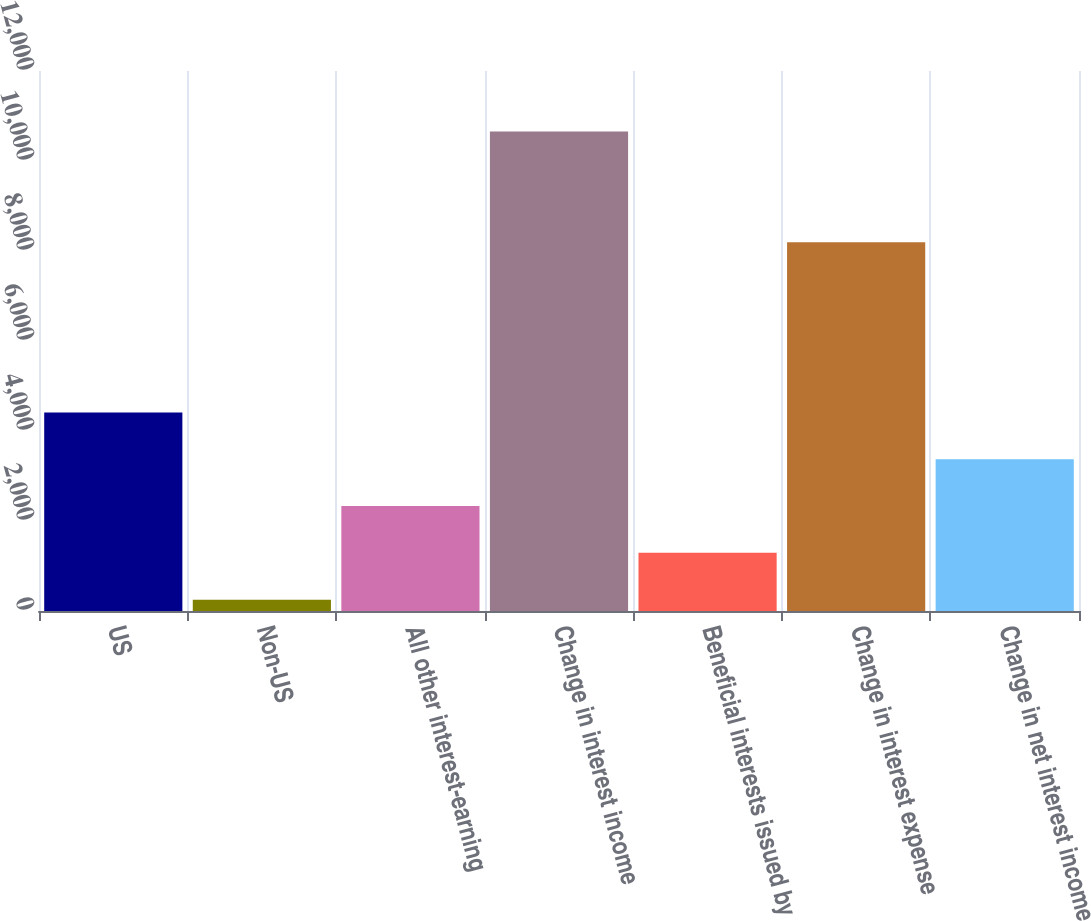Convert chart. <chart><loc_0><loc_0><loc_500><loc_500><bar_chart><fcel>US<fcel>Non-US<fcel>All other interest-earning<fcel>Change in interest income<fcel>Beneficial interests issued by<fcel>Change in interest expense<fcel>Change in net interest income<nl><fcel>4413.2<fcel>252<fcel>2332.6<fcel>10655<fcel>1292.3<fcel>8193<fcel>3372.9<nl></chart> 